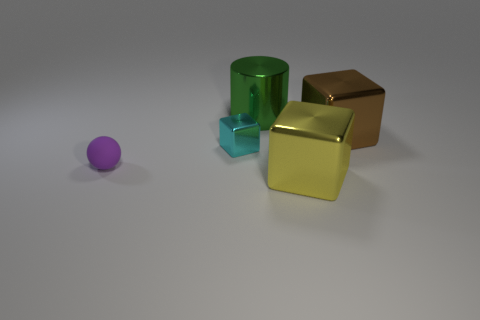What number of small cyan shiny objects have the same shape as the small purple rubber object?
Offer a very short reply. 0. There is a thing that is left of the big green cylinder and in front of the small block; what is its material?
Your response must be concise. Rubber. How many big shiny things are right of the brown thing?
Provide a short and direct response. 0. What number of red matte cylinders are there?
Provide a short and direct response. 0. Is the size of the cyan metallic cube the same as the rubber sphere?
Offer a very short reply. Yes. Are there any metal cubes left of the small thing that is behind the small thing on the left side of the small shiny cube?
Offer a terse response. No. What is the material of the tiny thing that is the same shape as the big yellow metal thing?
Your answer should be compact. Metal. What is the color of the big object right of the yellow shiny thing?
Give a very brief answer. Brown. What is the size of the brown metal thing?
Offer a very short reply. Large. Does the sphere have the same size as the object behind the brown shiny thing?
Your answer should be compact. No. 